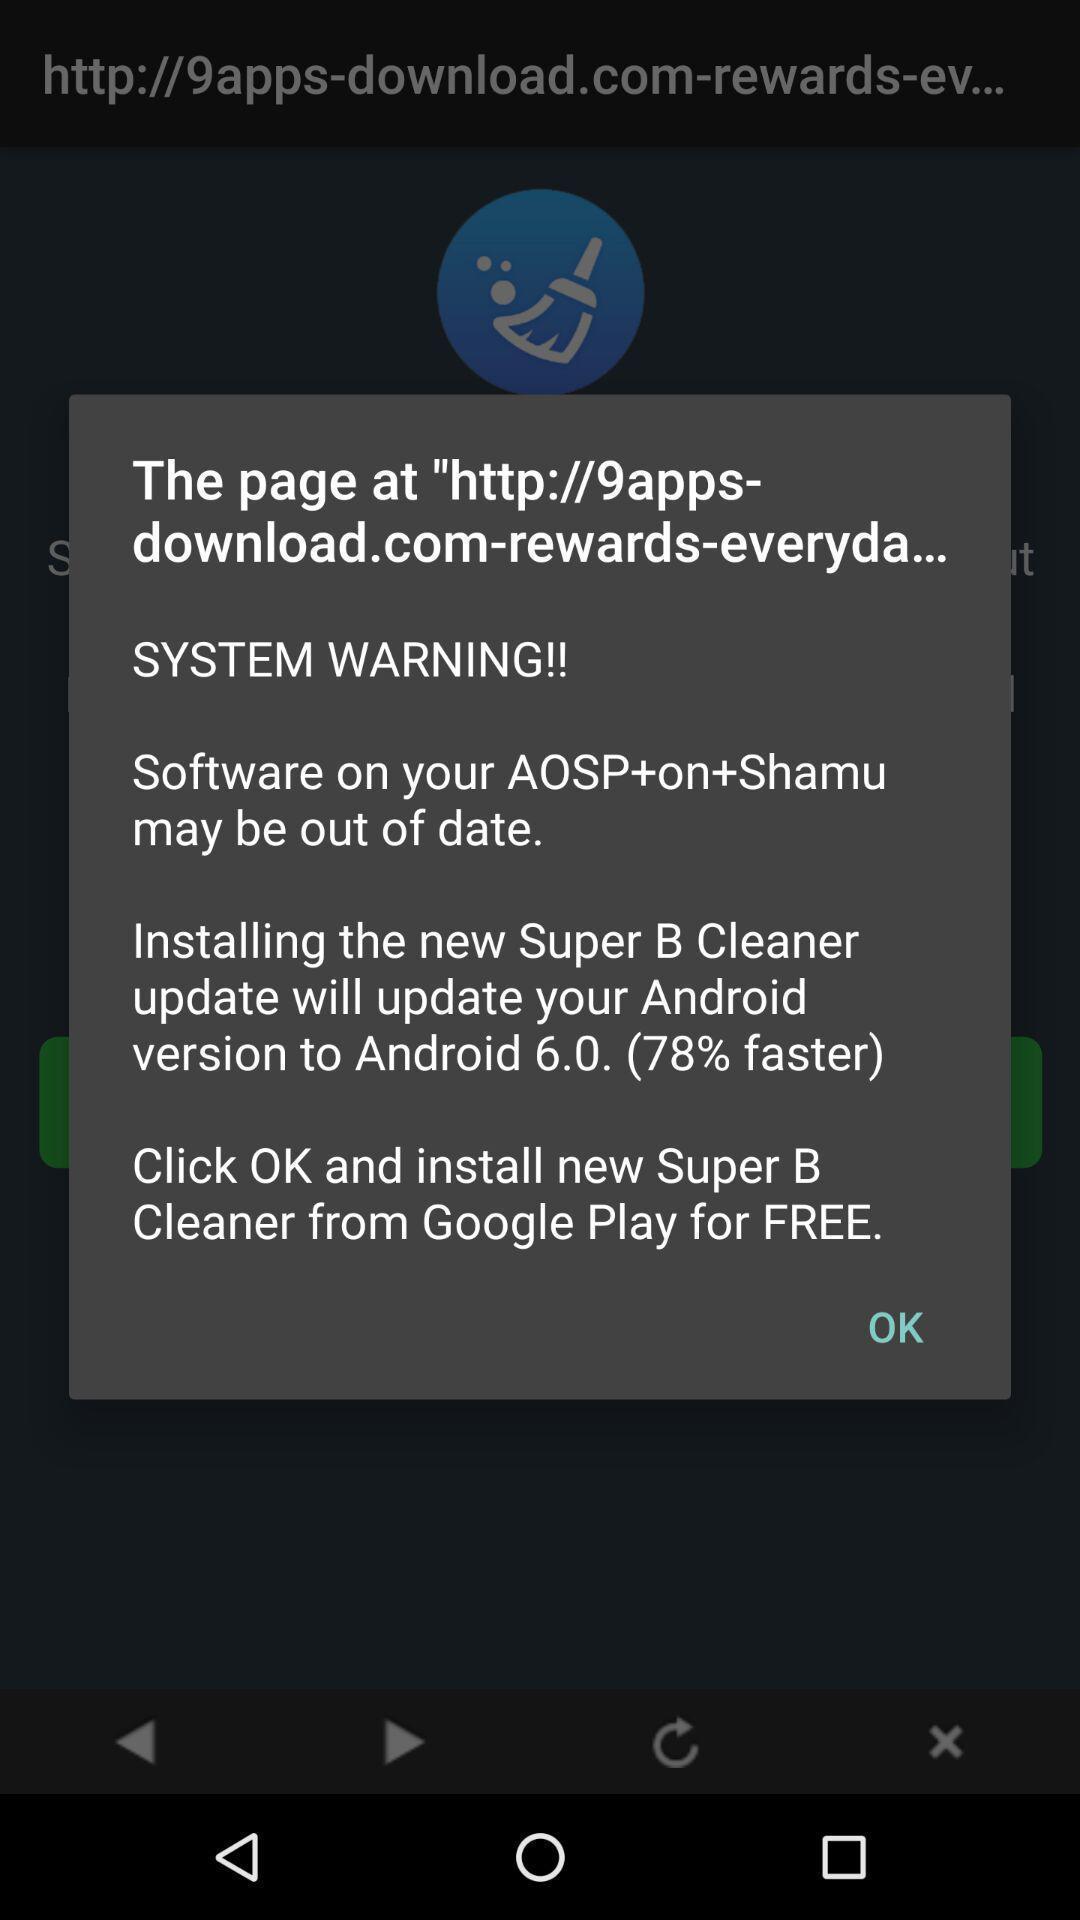Tell me about the visual elements in this screen capture. Pop-up showing the software update option. 